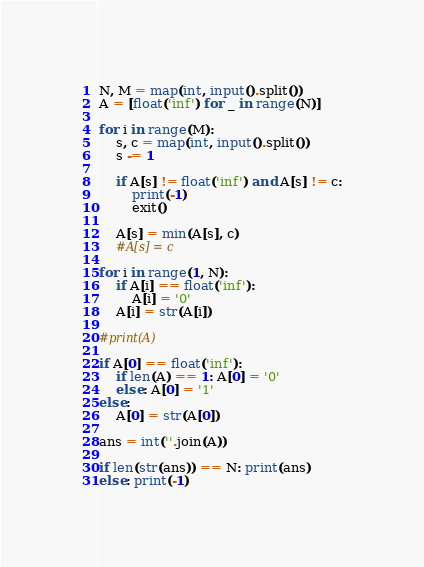Convert code to text. <code><loc_0><loc_0><loc_500><loc_500><_Python_>N, M = map(int, input().split())
A = [float('inf') for _ in range(N)]

for i in range(M):
    s, c = map(int, input().split())
    s -= 1
    
    if A[s] != float('inf') and A[s] != c:
        print(-1)
        exit()

    A[s] = min(A[s], c)
    #A[s] = c

for i in range(1, N):
    if A[i] == float('inf'):
        A[i] = '0'
    A[i] = str(A[i]) 

#print(A)

if A[0] == float('inf'):
    if len(A) == 1: A[0] = '0'
    else: A[0] = '1'
else:
    A[0] = str(A[0])

ans = int(''.join(A))

if len(str(ans)) == N: print(ans)
else: print(-1)
</code> 